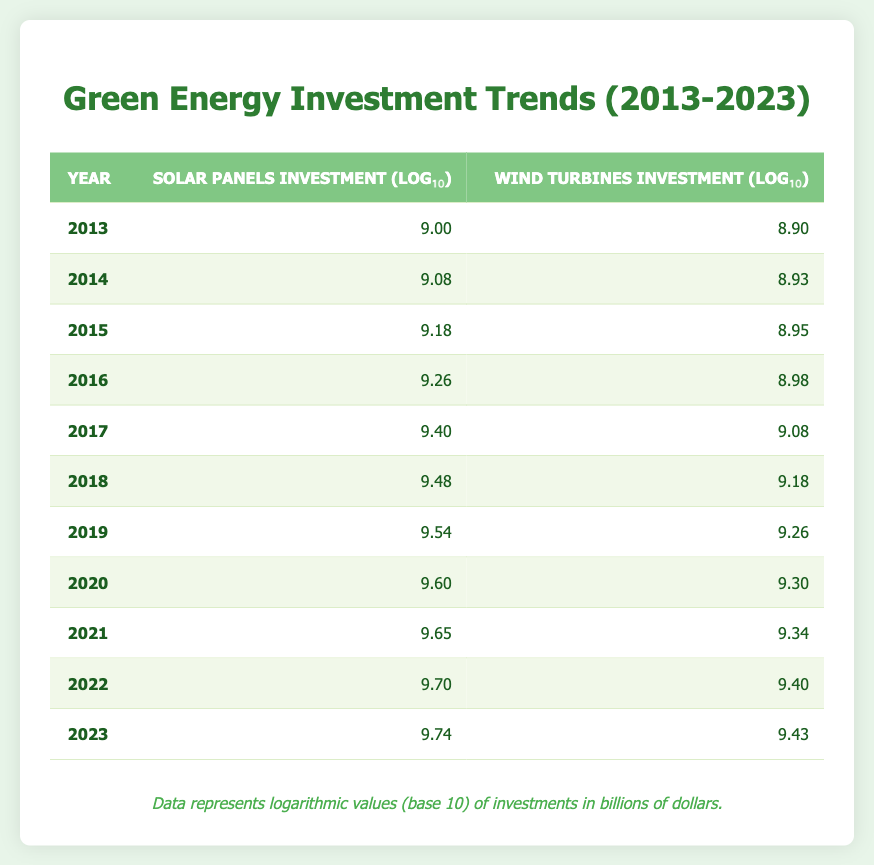What was the investment in solar panels and wind turbines in 2017? In 2017, the investment in solar panels was 2500000000 (in billions, log10 value is 9.40), and for wind turbines, it was 1200000000 (log10 value is 9.08).
Answer: Solar panels: 2500000000, Wind turbines: 1200000000 Which year saw the highest investment in wind turbines? Looking at the table, the highest investment in wind turbines occurred in 2022, with an investment of 2500000000 (log10 value is 9.40).
Answer: 2022 What was the difference in logarithmic investment values between solar panels and wind turbines in 2018? In 2018, the log10 value for solar panel investment was 9.48 and for wind turbines, it was 9.18. The difference is 9.48 - 9.18 = 0.30.
Answer: 0.30 Is it true that the investment in wind turbines increased every year from 2013 to 2023? By examining the table row by row, investment in wind turbines steadily increased from 800000000 (in 2013) to 2700000000 (in 2023), confirming that it increased every year.
Answer: Yes What is the average logarithmic investment in solar panels from 2015 to 2020? To find the average, sum the investment values from these years: 9.18 (2015) + 9.26 (2016) + 9.40 (2017) + 9.48 (2018) + 9.60 (2019) + 9.65 (2020) = 55.17. There are 6 years, so the average is 55.17 / 6 = 9.19.
Answer: 9.19 How much was the solar panels investment for 2023 compared to the investment in 2013? In 2023, the solar panels investment was 5500000000 (log10 value is 9.74), while in 2013 it was 1000000000 (log10 value is 9.00). The investment increased by 5500000000 - 1000000000 = 4500000000.
Answer: 4500000000 What was the investment in solar panels in 2014? From the table, the investment in solar panels for 2014 is recorded as 1200000000 (log10 value is 9.08).
Answer: 1200000000 In what year did the solar panel investment first exceed 4000000000? The first instance the solar panel investment exceeded 4000000000 occurred in 2020, where it reached 4000000000 (log10 value is 9.60).
Answer: 2020 